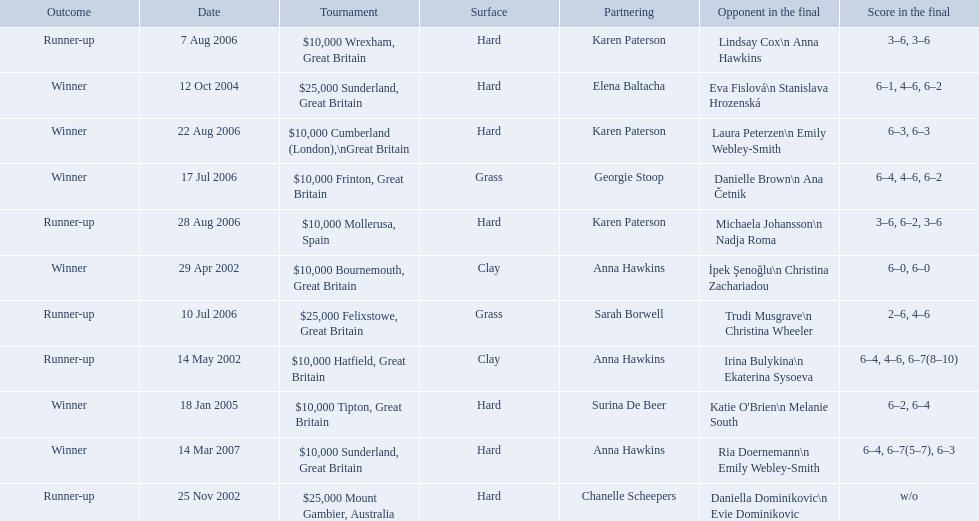How many tournaments has jane o'donoghue competed in? 11. 